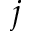<formula> <loc_0><loc_0><loc_500><loc_500>j</formula> 